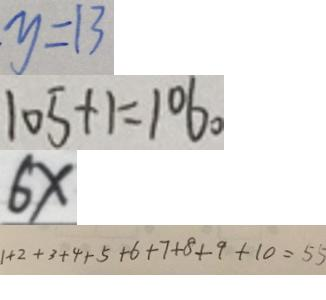<formula> <loc_0><loc_0><loc_500><loc_500>y = 1 3 
 1 0 5 + 1 = 1 0 6 。 
 6 x 
 1 + 2 + 3 + 4 + 5 + 6 + 7 + 8 + 9 + 1 0 = 5 5</formula> 